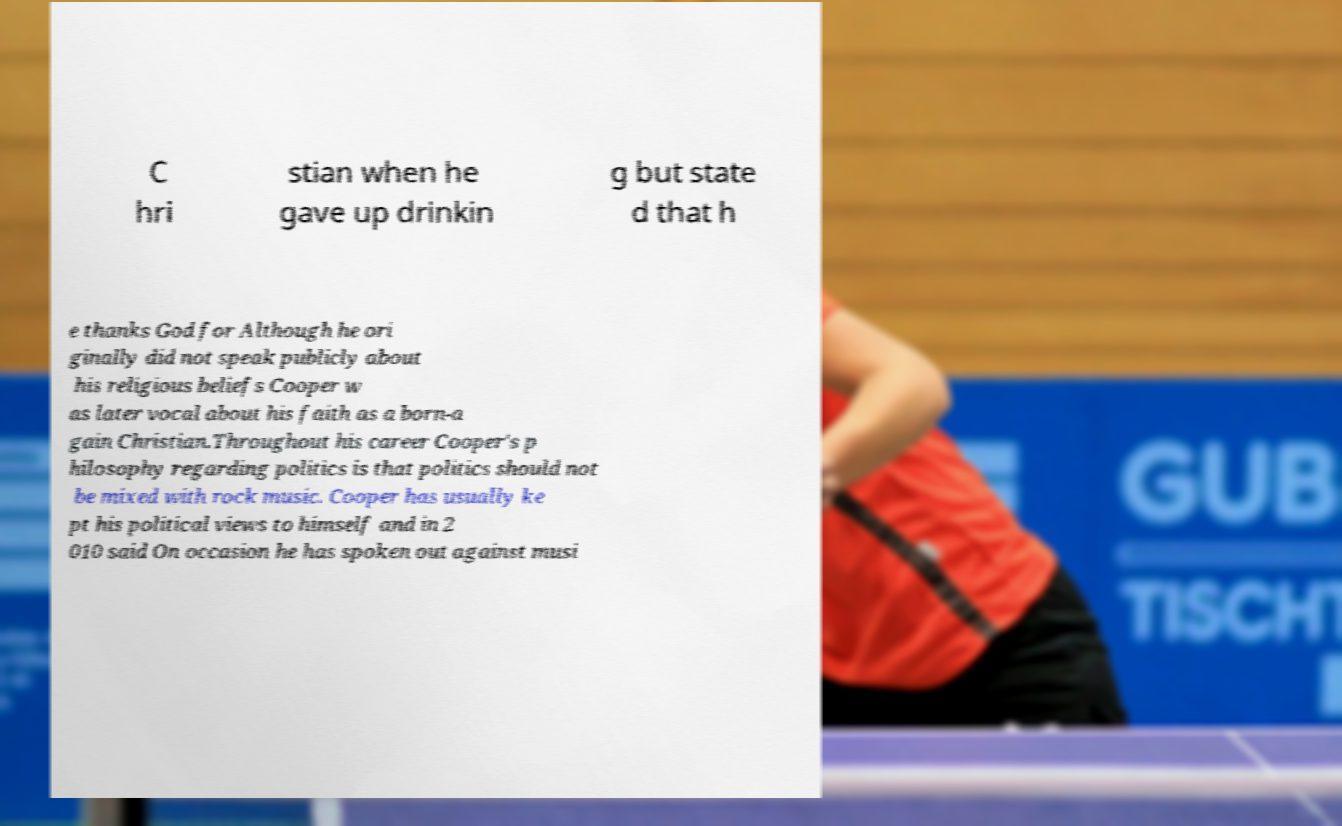I need the written content from this picture converted into text. Can you do that? C hri stian when he gave up drinkin g but state d that h e thanks God for Although he ori ginally did not speak publicly about his religious beliefs Cooper w as later vocal about his faith as a born-a gain Christian.Throughout his career Cooper's p hilosophy regarding politics is that politics should not be mixed with rock music. Cooper has usually ke pt his political views to himself and in 2 010 said On occasion he has spoken out against musi 